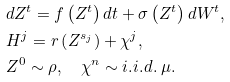Convert formula to latex. <formula><loc_0><loc_0><loc_500><loc_500>& d Z ^ { t } = f \left ( Z ^ { t } \right ) d t + \sigma \left ( Z ^ { t } \right ) d W ^ { t } , \\ & H ^ { j } = r \left ( Z ^ { s _ { j } } \right ) + \chi ^ { j } , \\ & Z ^ { 0 } \sim \rho , \quad \chi ^ { n } \sim i . i . d . \ \mu .</formula> 